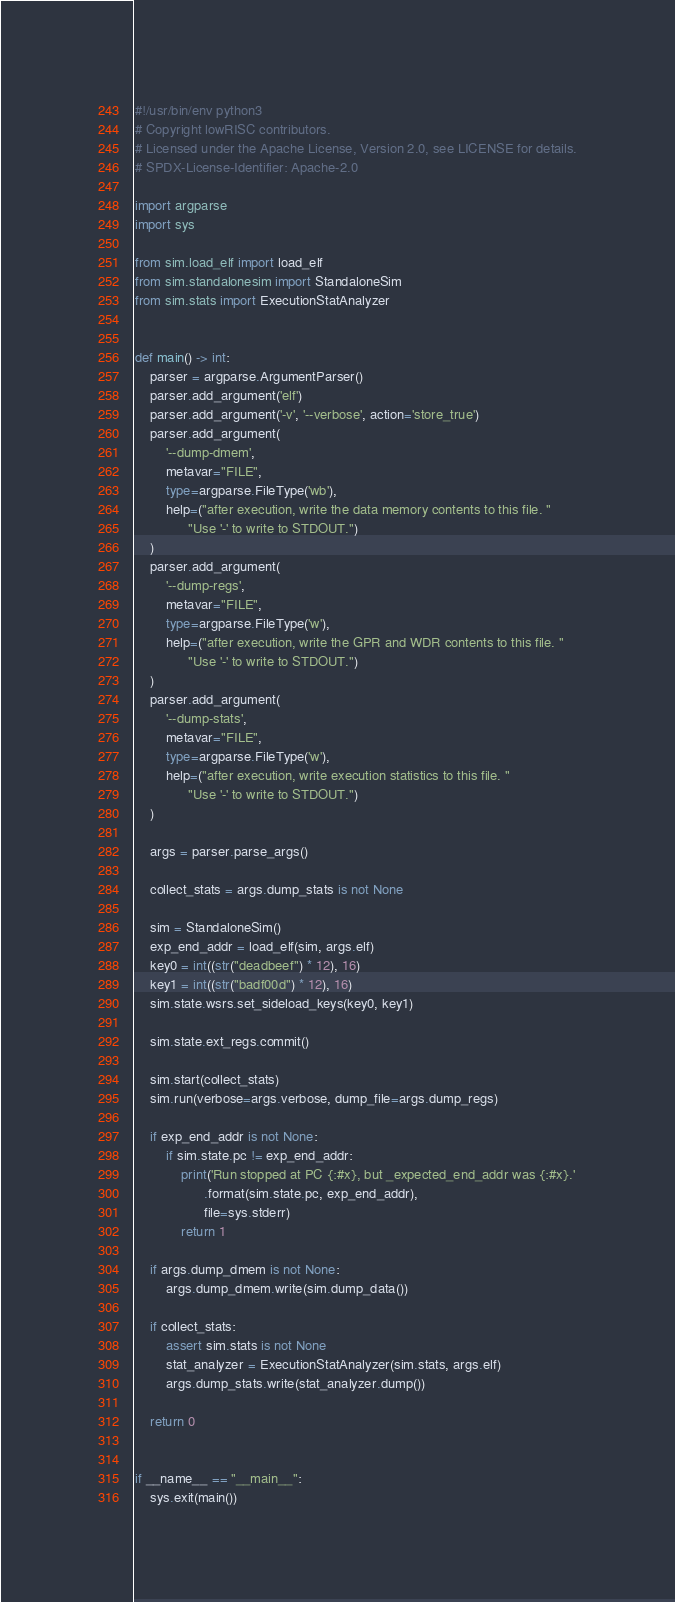<code> <loc_0><loc_0><loc_500><loc_500><_Python_>#!/usr/bin/env python3
# Copyright lowRISC contributors.
# Licensed under the Apache License, Version 2.0, see LICENSE for details.
# SPDX-License-Identifier: Apache-2.0

import argparse
import sys

from sim.load_elf import load_elf
from sim.standalonesim import StandaloneSim
from sim.stats import ExecutionStatAnalyzer


def main() -> int:
    parser = argparse.ArgumentParser()
    parser.add_argument('elf')
    parser.add_argument('-v', '--verbose', action='store_true')
    parser.add_argument(
        '--dump-dmem',
        metavar="FILE",
        type=argparse.FileType('wb'),
        help=("after execution, write the data memory contents to this file. "
              "Use '-' to write to STDOUT.")
    )
    parser.add_argument(
        '--dump-regs',
        metavar="FILE",
        type=argparse.FileType('w'),
        help=("after execution, write the GPR and WDR contents to this file. "
              "Use '-' to write to STDOUT.")
    )
    parser.add_argument(
        '--dump-stats',
        metavar="FILE",
        type=argparse.FileType('w'),
        help=("after execution, write execution statistics to this file. "
              "Use '-' to write to STDOUT.")
    )

    args = parser.parse_args()

    collect_stats = args.dump_stats is not None

    sim = StandaloneSim()
    exp_end_addr = load_elf(sim, args.elf)
    key0 = int((str("deadbeef") * 12), 16)
    key1 = int((str("badf00d") * 12), 16)
    sim.state.wsrs.set_sideload_keys(key0, key1)

    sim.state.ext_regs.commit()

    sim.start(collect_stats)
    sim.run(verbose=args.verbose, dump_file=args.dump_regs)

    if exp_end_addr is not None:
        if sim.state.pc != exp_end_addr:
            print('Run stopped at PC {:#x}, but _expected_end_addr was {:#x}.'
                  .format(sim.state.pc, exp_end_addr),
                  file=sys.stderr)
            return 1

    if args.dump_dmem is not None:
        args.dump_dmem.write(sim.dump_data())

    if collect_stats:
        assert sim.stats is not None
        stat_analyzer = ExecutionStatAnalyzer(sim.stats, args.elf)
        args.dump_stats.write(stat_analyzer.dump())

    return 0


if __name__ == "__main__":
    sys.exit(main())
</code> 